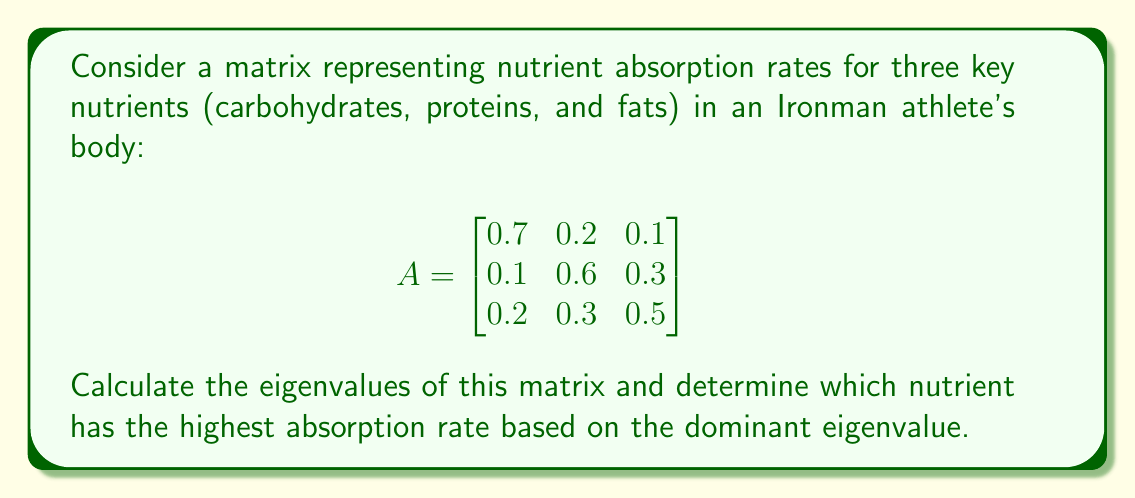Could you help me with this problem? 1) To find the eigenvalues, we need to solve the characteristic equation:
   $$det(A - \lambda I) = 0$$

2) Expanding the determinant:
   $$\begin{vmatrix}
   0.7-\lambda & 0.2 & 0.1 \\
   0.1 & 0.6-\lambda & 0.3 \\
   0.2 & 0.3 & 0.5-\lambda
   \end{vmatrix} = 0$$

3) This gives us the cubic equation:
   $$-\lambda^3 + 1.8\lambda^2 - 0.93\lambda + 0.138 = 0$$

4) Using the cubic formula or numerical methods, we find the eigenvalues:
   $$\lambda_1 \approx 1$$
   $$\lambda_2 \approx 0.5$$
   $$\lambda_3 \approx 0.3$$

5) The dominant eigenvalue is $\lambda_1 \approx 1$.

6) To determine which nutrient corresponds to this eigenvalue, we need to find the eigenvector associated with $\lambda_1$. However, given the structure of the matrix, we can see that the first row (corresponding to carbohydrates) has the largest diagonal element (0.7), which is closest to the dominant eigenvalue.

7) Therefore, based on this analysis, carbohydrates have the highest absorption rate.
Answer: Carbohydrates (dominant eigenvalue ≈ 1) 